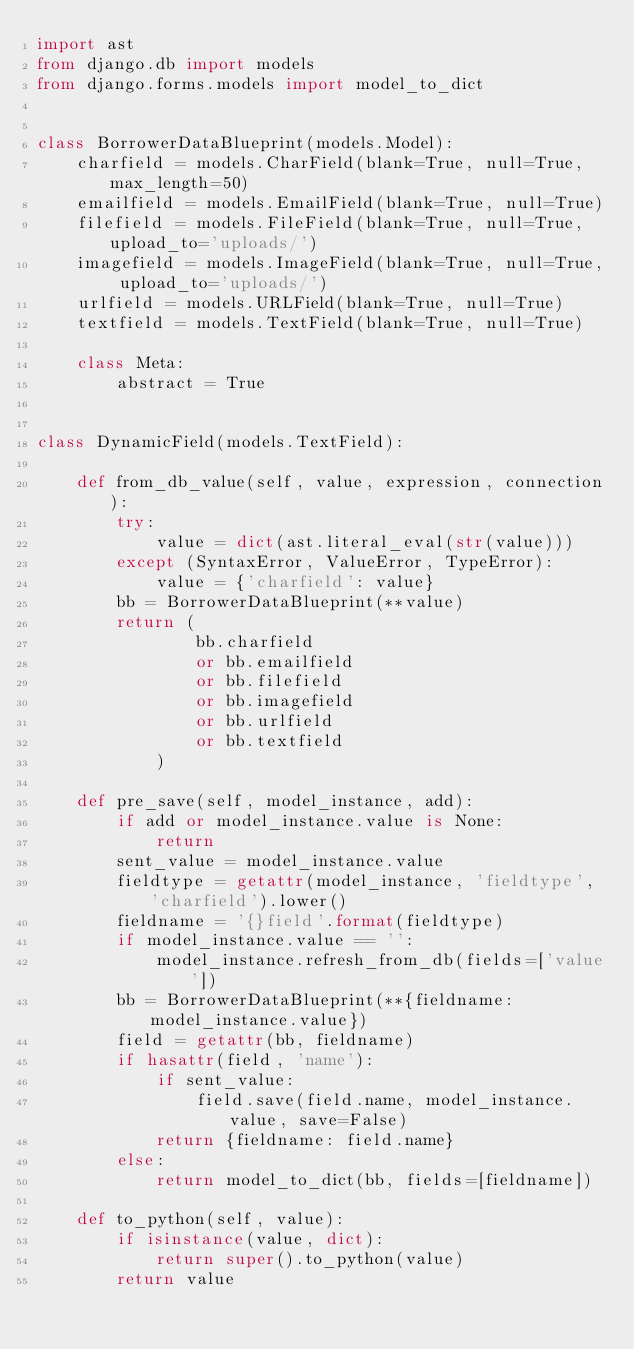<code> <loc_0><loc_0><loc_500><loc_500><_Python_>import ast
from django.db import models
from django.forms.models import model_to_dict


class BorrowerDataBlueprint(models.Model):
    charfield = models.CharField(blank=True, null=True, max_length=50)
    emailfield = models.EmailField(blank=True, null=True)
    filefield = models.FileField(blank=True, null=True, upload_to='uploads/')
    imagefield = models.ImageField(blank=True, null=True, upload_to='uploads/')
    urlfield = models.URLField(blank=True, null=True)
    textfield = models.TextField(blank=True, null=True)

    class Meta:
        abstract = True


class DynamicField(models.TextField):

    def from_db_value(self, value, expression, connection):
        try:
            value = dict(ast.literal_eval(str(value)))
        except (SyntaxError, ValueError, TypeError):
            value = {'charfield': value}
        bb = BorrowerDataBlueprint(**value)
        return (
                bb.charfield
                or bb.emailfield
                or bb.filefield
                or bb.imagefield
                or bb.urlfield
                or bb.textfield
            )

    def pre_save(self, model_instance, add):
        if add or model_instance.value is None:
            return
        sent_value = model_instance.value
        fieldtype = getattr(model_instance, 'fieldtype', 'charfield').lower()
        fieldname = '{}field'.format(fieldtype)
        if model_instance.value == '':
            model_instance.refresh_from_db(fields=['value'])
        bb = BorrowerDataBlueprint(**{fieldname: model_instance.value})
        field = getattr(bb, fieldname)
        if hasattr(field, 'name'):
            if sent_value:
                field.save(field.name, model_instance.value, save=False)
            return {fieldname: field.name}
        else:
            return model_to_dict(bb, fields=[fieldname])

    def to_python(self, value):
        if isinstance(value, dict):
            return super().to_python(value)
        return value
</code> 